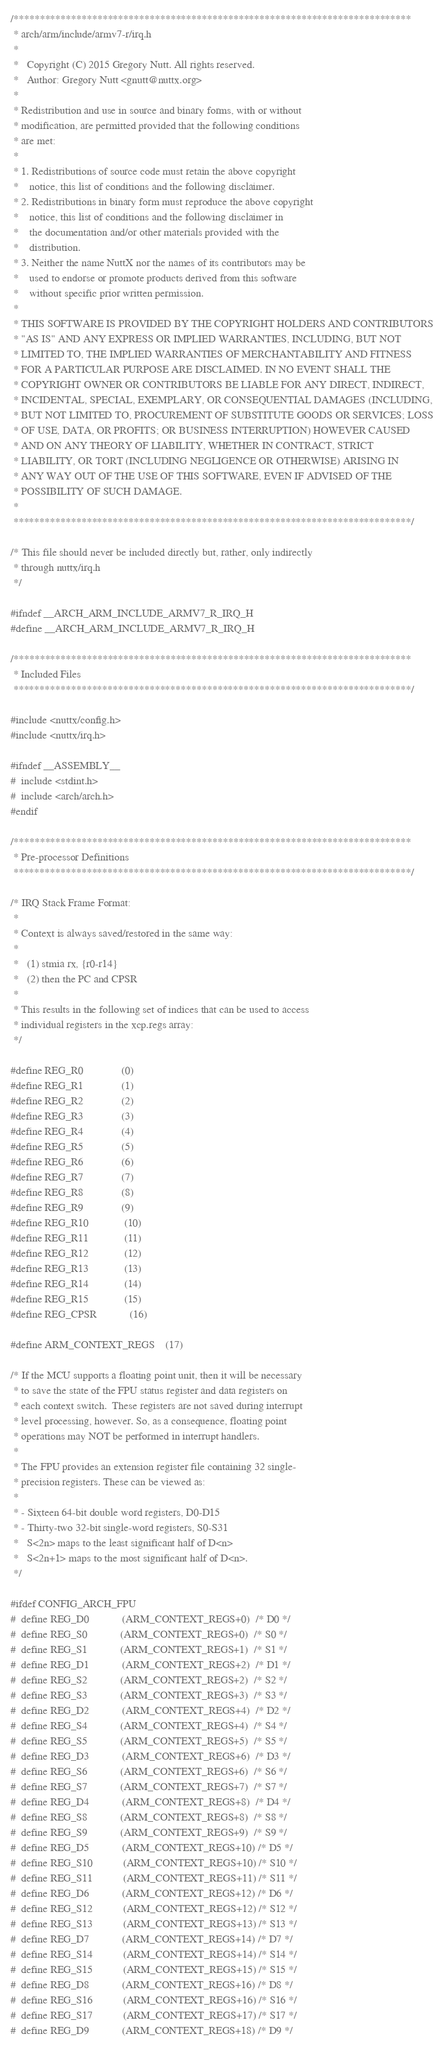Convert code to text. <code><loc_0><loc_0><loc_500><loc_500><_C_>/****************************************************************************
 * arch/arm/include/armv7-r/irq.h
 *
 *   Copyright (C) 2015 Gregory Nutt. All rights reserved.
 *   Author: Gregory Nutt <gnutt@nuttx.org>
 *
 * Redistribution and use in source and binary forms, with or without
 * modification, are permitted provided that the following conditions
 * are met:
 *
 * 1. Redistributions of source code must retain the above copyright
 *    notice, this list of conditions and the following disclaimer.
 * 2. Redistributions in binary form must reproduce the above copyright
 *    notice, this list of conditions and the following disclaimer in
 *    the documentation and/or other materials provided with the
 *    distribution.
 * 3. Neither the name NuttX nor the names of its contributors may be
 *    used to endorse or promote products derived from this software
 *    without specific prior written permission.
 *
 * THIS SOFTWARE IS PROVIDED BY THE COPYRIGHT HOLDERS AND CONTRIBUTORS
 * "AS IS" AND ANY EXPRESS OR IMPLIED WARRANTIES, INCLUDING, BUT NOT
 * LIMITED TO, THE IMPLIED WARRANTIES OF MERCHANTABILITY AND FITNESS
 * FOR A PARTICULAR PURPOSE ARE DISCLAIMED. IN NO EVENT SHALL THE
 * COPYRIGHT OWNER OR CONTRIBUTORS BE LIABLE FOR ANY DIRECT, INDIRECT,
 * INCIDENTAL, SPECIAL, EXEMPLARY, OR CONSEQUENTIAL DAMAGES (INCLUDING,
 * BUT NOT LIMITED TO, PROCUREMENT OF SUBSTITUTE GOODS OR SERVICES; LOSS
 * OF USE, DATA, OR PROFITS; OR BUSINESS INTERRUPTION) HOWEVER CAUSED
 * AND ON ANY THEORY OF LIABILITY, WHETHER IN CONTRACT, STRICT
 * LIABILITY, OR TORT (INCLUDING NEGLIGENCE OR OTHERWISE) ARISING IN
 * ANY WAY OUT OF THE USE OF THIS SOFTWARE, EVEN IF ADVISED OF THE
 * POSSIBILITY OF SUCH DAMAGE.
 *
 ****************************************************************************/

/* This file should never be included directly but, rather, only indirectly
 * through nuttx/irq.h
 */

#ifndef __ARCH_ARM_INCLUDE_ARMV7_R_IRQ_H
#define __ARCH_ARM_INCLUDE_ARMV7_R_IRQ_H

/****************************************************************************
 * Included Files
 ****************************************************************************/

#include <nuttx/config.h>
#include <nuttx/irq.h>

#ifndef __ASSEMBLY__
#  include <stdint.h>
#  include <arch/arch.h>
#endif

/****************************************************************************
 * Pre-processor Definitions
 ****************************************************************************/

/* IRQ Stack Frame Format:
 *
 * Context is always saved/restored in the same way:
 *
 *   (1) stmia rx, {r0-r14}
 *   (2) then the PC and CPSR
 *
 * This results in the following set of indices that can be used to access
 * individual registers in the xcp.regs array:
 */

#define REG_R0              (0)
#define REG_R1              (1)
#define REG_R2              (2)
#define REG_R3              (3)
#define REG_R4              (4)
#define REG_R5              (5)
#define REG_R6              (6)
#define REG_R7              (7)
#define REG_R8              (8)
#define REG_R9              (9)
#define REG_R10             (10)
#define REG_R11             (11)
#define REG_R12             (12)
#define REG_R13             (13)
#define REG_R14             (14)
#define REG_R15             (15)
#define REG_CPSR            (16)

#define ARM_CONTEXT_REGS    (17)

/* If the MCU supports a floating point unit, then it will be necessary
 * to save the state of the FPU status register and data registers on
 * each context switch.  These registers are not saved during interrupt
 * level processing, however. So, as a consequence, floating point
 * operations may NOT be performed in interrupt handlers.
 *
 * The FPU provides an extension register file containing 32 single-
 * precision registers. These can be viewed as:
 *
 * - Sixteen 64-bit double word registers, D0-D15
 * - Thirty-two 32-bit single-word registers, S0-S31
 *   S<2n> maps to the least significant half of D<n>
 *   S<2n+1> maps to the most significant half of D<n>.
 */

#ifdef CONFIG_ARCH_FPU
#  define REG_D0            (ARM_CONTEXT_REGS+0)  /* D0 */
#  define REG_S0            (ARM_CONTEXT_REGS+0)  /* S0 */
#  define REG_S1            (ARM_CONTEXT_REGS+1)  /* S1 */
#  define REG_D1            (ARM_CONTEXT_REGS+2)  /* D1 */
#  define REG_S2            (ARM_CONTEXT_REGS+2)  /* S2 */
#  define REG_S3            (ARM_CONTEXT_REGS+3)  /* S3 */
#  define REG_D2            (ARM_CONTEXT_REGS+4)  /* D2 */
#  define REG_S4            (ARM_CONTEXT_REGS+4)  /* S4 */
#  define REG_S5            (ARM_CONTEXT_REGS+5)  /* S5 */
#  define REG_D3            (ARM_CONTEXT_REGS+6)  /* D3 */
#  define REG_S6            (ARM_CONTEXT_REGS+6)  /* S6 */
#  define REG_S7            (ARM_CONTEXT_REGS+7)  /* S7 */
#  define REG_D4            (ARM_CONTEXT_REGS+8)  /* D4 */
#  define REG_S8            (ARM_CONTEXT_REGS+8)  /* S8 */
#  define REG_S9            (ARM_CONTEXT_REGS+9)  /* S9 */
#  define REG_D5            (ARM_CONTEXT_REGS+10) /* D5 */
#  define REG_S10           (ARM_CONTEXT_REGS+10) /* S10 */
#  define REG_S11           (ARM_CONTEXT_REGS+11) /* S11 */
#  define REG_D6            (ARM_CONTEXT_REGS+12) /* D6 */
#  define REG_S12           (ARM_CONTEXT_REGS+12) /* S12 */
#  define REG_S13           (ARM_CONTEXT_REGS+13) /* S13 */
#  define REG_D7            (ARM_CONTEXT_REGS+14) /* D7 */
#  define REG_S14           (ARM_CONTEXT_REGS+14) /* S14 */
#  define REG_S15           (ARM_CONTEXT_REGS+15) /* S15 */
#  define REG_D8            (ARM_CONTEXT_REGS+16) /* D8 */
#  define REG_S16           (ARM_CONTEXT_REGS+16) /* S16 */
#  define REG_S17           (ARM_CONTEXT_REGS+17) /* S17 */
#  define REG_D9            (ARM_CONTEXT_REGS+18) /* D9 */</code> 